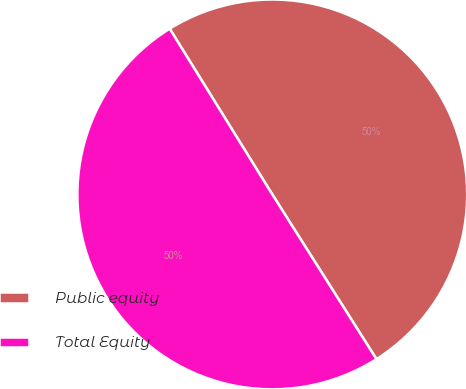Convert chart. <chart><loc_0><loc_0><loc_500><loc_500><pie_chart><fcel>Public equity<fcel>Total Equity<nl><fcel>49.85%<fcel>50.15%<nl></chart> 